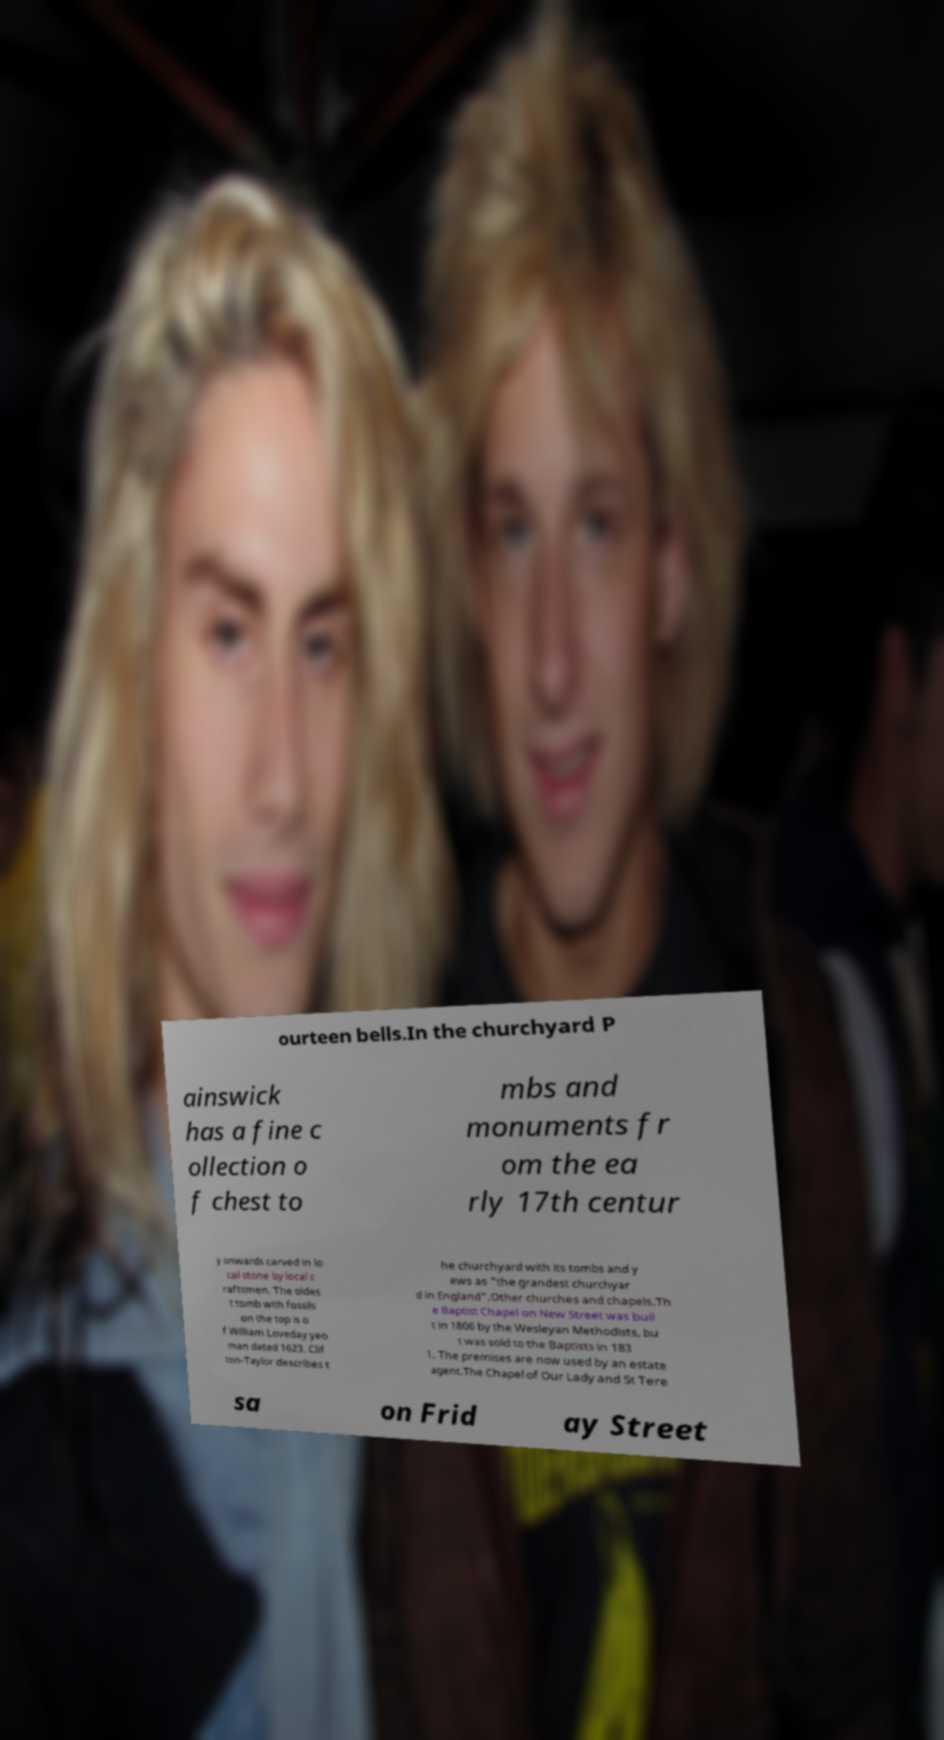Please read and relay the text visible in this image. What does it say? ourteen bells.In the churchyard P ainswick has a fine c ollection o f chest to mbs and monuments fr om the ea rly 17th centur y onwards carved in lo cal stone by local c raftsmen. The oldes t tomb with fossils on the top is o f William Loveday yeo man dated 1623. Clif ton-Taylor describes t he churchyard with its tombs and y ews as "the grandest churchyar d in England".Other churches and chapels.Th e Baptist Chapel on New Street was buil t in 1806 by the Wesleyan Methodists, bu t was sold to the Baptists in 183 1. The premises are now used by an estate agent.The Chapel of Our Lady and St Tere sa on Frid ay Street 